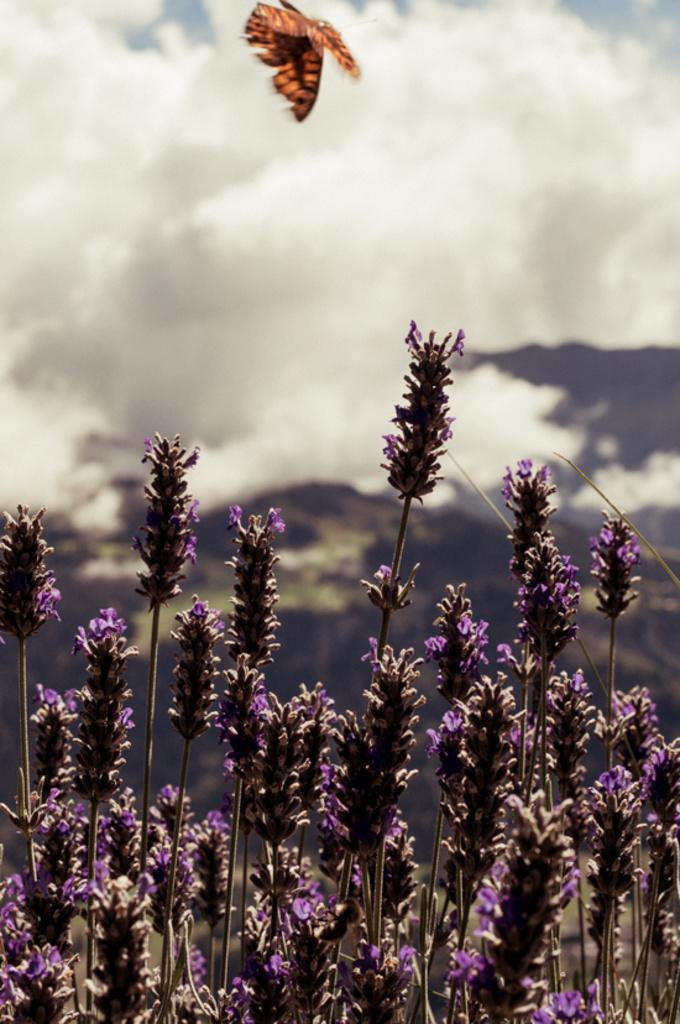What type of plants can be seen in the image? There are plants with flowers in the image. What is flying in the air in the image? There is a butterfly flying in the air in the image. What can be seen in the background of the image? The sky is visible in the background of the image. What else is present in the sky? Clouds are present in the sky. What type of engine is powering the butterfly in the image? There is no engine present in the image; the butterfly is flying naturally. How many knives are visible in the image? There are no knives present in the image. 